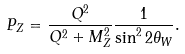<formula> <loc_0><loc_0><loc_500><loc_500>P _ { Z } = \frac { Q ^ { 2 } } { Q ^ { 2 } + M _ { Z } ^ { 2 } } \frac { 1 } { \sin ^ { 2 } 2 \theta _ { W } } .</formula> 